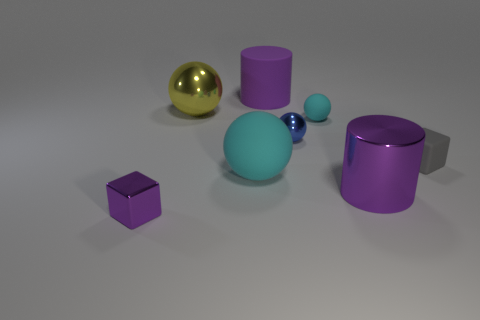What is the color of the cube on the left side of the cyan matte thing that is in front of the small cube right of the big metal cylinder?
Your answer should be very brief. Purple. What number of metal objects are either tiny cyan cubes or small gray objects?
Your response must be concise. 0. Are there more balls right of the large cyan rubber thing than purple rubber objects that are on the right side of the tiny cyan sphere?
Keep it short and to the point. Yes. How many other things are there of the same size as the yellow shiny thing?
Keep it short and to the point. 3. There is a rubber thing on the right side of the purple metal thing that is to the right of the tiny blue shiny object; how big is it?
Provide a succinct answer. Small. What number of large things are cylinders or cyan objects?
Provide a short and direct response. 3. What size is the cyan matte object left of the purple cylinder behind the matte thing right of the tiny matte sphere?
Your answer should be compact. Large. Are there any other things that have the same color as the small rubber sphere?
Offer a very short reply. Yes. The large object on the right side of the small metal thing that is on the right side of the object on the left side of the big yellow thing is made of what material?
Offer a very short reply. Metal. Is the shape of the gray object the same as the small blue shiny object?
Your response must be concise. No. 